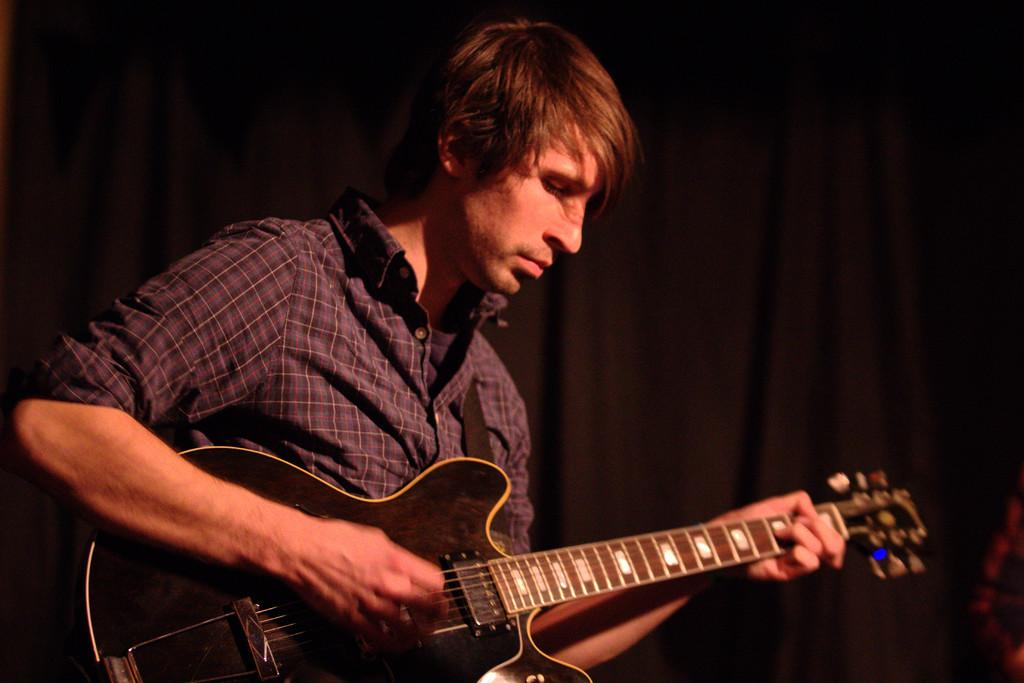What is the main subject of the image? There is a person in the image. What is the person doing in the image? The person is sitting and playing a guitar. What can be observed about the background of the image? The background of the image is black in color. How many books are visible on the border of the image? There are no books present in the image, and there is no border visible. 